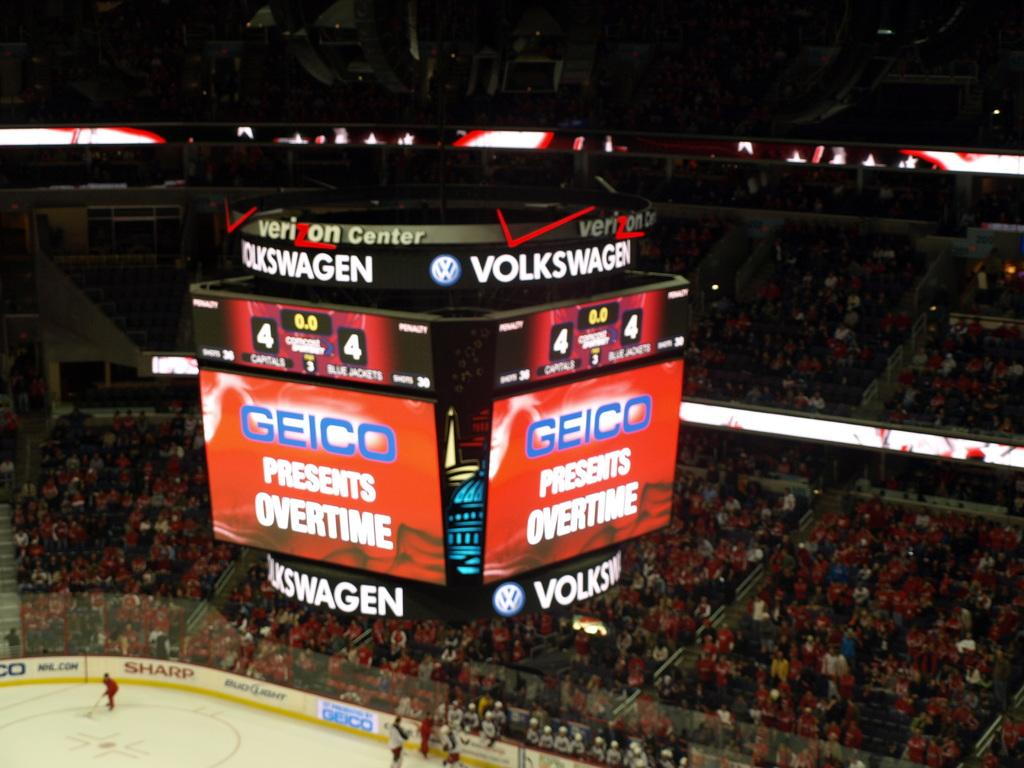<image>
Describe the image concisely. Scoreboard inside a hockey arena that says "Geico" on top. 